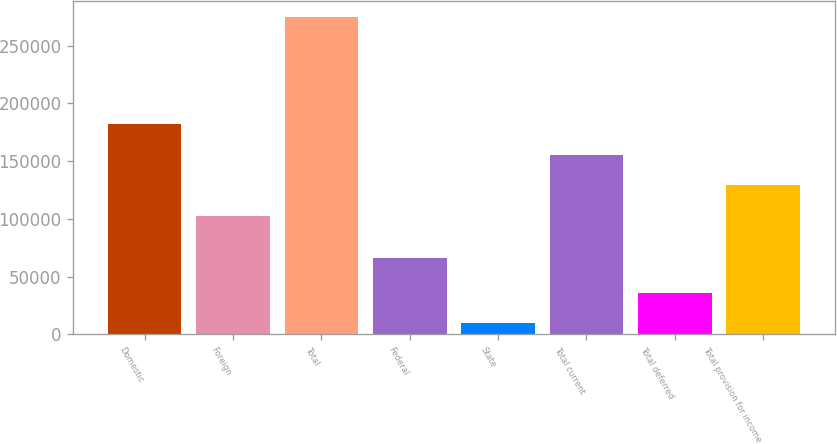<chart> <loc_0><loc_0><loc_500><loc_500><bar_chart><fcel>Domestic<fcel>Foreign<fcel>Total<fcel>Federal<fcel>State<fcel>Total current<fcel>Total deferred<fcel>Total provision for income<nl><fcel>182010<fcel>102421<fcel>274752<fcel>65869<fcel>9455<fcel>155480<fcel>35984.7<fcel>128951<nl></chart> 